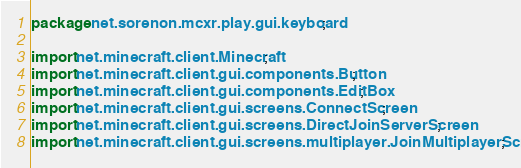Convert code to text. <code><loc_0><loc_0><loc_500><loc_500><_Java_>package net.sorenon.mcxr.play.gui.keyboard;

import net.minecraft.client.Minecraft;
import net.minecraft.client.gui.components.Button;
import net.minecraft.client.gui.components.EditBox;
import net.minecraft.client.gui.screens.ConnectScreen;
import net.minecraft.client.gui.screens.DirectJoinServerScreen;
import net.minecraft.client.gui.screens.multiplayer.JoinMultiplayerScreen;</code> 